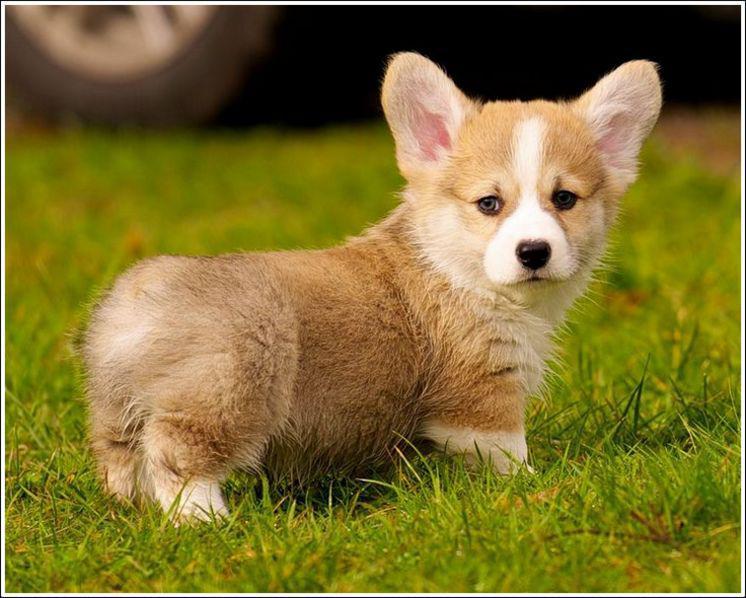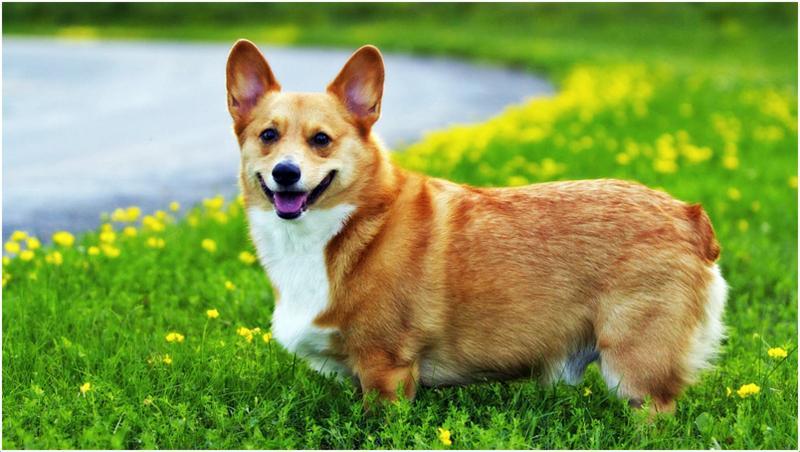The first image is the image on the left, the second image is the image on the right. Examine the images to the left and right. Is the description "The dog in the image on the right is on grass." accurate? Answer yes or no. Yes. The first image is the image on the left, the second image is the image on the right. Considering the images on both sides, is "One of the dogs is wearing a collar with no charms." valid? Answer yes or no. No. 